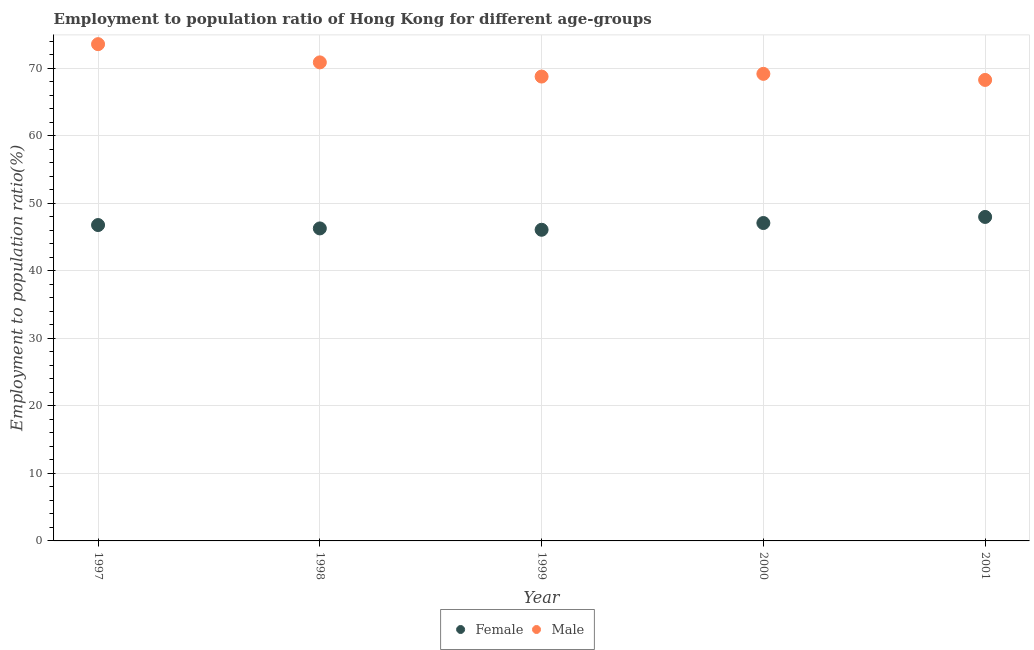Is the number of dotlines equal to the number of legend labels?
Offer a terse response. Yes. What is the employment to population ratio(male) in 1998?
Keep it short and to the point. 70.9. Across all years, what is the maximum employment to population ratio(female)?
Provide a succinct answer. 48. Across all years, what is the minimum employment to population ratio(female)?
Give a very brief answer. 46.1. In which year was the employment to population ratio(male) minimum?
Your answer should be very brief. 2001. What is the total employment to population ratio(male) in the graph?
Your answer should be very brief. 350.8. What is the difference between the employment to population ratio(female) in 1997 and that in 1998?
Give a very brief answer. 0.5. What is the difference between the employment to population ratio(female) in 1997 and the employment to population ratio(male) in 2001?
Offer a terse response. -21.5. What is the average employment to population ratio(female) per year?
Your response must be concise. 46.86. In the year 2000, what is the difference between the employment to population ratio(female) and employment to population ratio(male)?
Keep it short and to the point. -22.1. What is the ratio of the employment to population ratio(male) in 1999 to that in 2000?
Provide a succinct answer. 0.99. Is the employment to population ratio(male) in 1997 less than that in 2000?
Provide a short and direct response. No. What is the difference between the highest and the second highest employment to population ratio(female)?
Keep it short and to the point. 0.9. What is the difference between the highest and the lowest employment to population ratio(male)?
Your answer should be compact. 5.3. In how many years, is the employment to population ratio(female) greater than the average employment to population ratio(female) taken over all years?
Keep it short and to the point. 2. Is the sum of the employment to population ratio(male) in 2000 and 2001 greater than the maximum employment to population ratio(female) across all years?
Make the answer very short. Yes. Is the employment to population ratio(male) strictly greater than the employment to population ratio(female) over the years?
Offer a terse response. Yes. Is the employment to population ratio(male) strictly less than the employment to population ratio(female) over the years?
Your answer should be very brief. No. How many dotlines are there?
Keep it short and to the point. 2. How many years are there in the graph?
Make the answer very short. 5. What is the difference between two consecutive major ticks on the Y-axis?
Your response must be concise. 10. Does the graph contain any zero values?
Give a very brief answer. No. How many legend labels are there?
Your response must be concise. 2. What is the title of the graph?
Your answer should be very brief. Employment to population ratio of Hong Kong for different age-groups. Does "Domestic Liabilities" appear as one of the legend labels in the graph?
Provide a succinct answer. No. What is the label or title of the X-axis?
Give a very brief answer. Year. What is the label or title of the Y-axis?
Provide a succinct answer. Employment to population ratio(%). What is the Employment to population ratio(%) of Female in 1997?
Your answer should be very brief. 46.8. What is the Employment to population ratio(%) of Male in 1997?
Keep it short and to the point. 73.6. What is the Employment to population ratio(%) of Female in 1998?
Offer a very short reply. 46.3. What is the Employment to population ratio(%) in Male in 1998?
Keep it short and to the point. 70.9. What is the Employment to population ratio(%) of Female in 1999?
Your answer should be very brief. 46.1. What is the Employment to population ratio(%) of Male in 1999?
Keep it short and to the point. 68.8. What is the Employment to population ratio(%) of Female in 2000?
Your answer should be compact. 47.1. What is the Employment to population ratio(%) in Male in 2000?
Provide a succinct answer. 69.2. What is the Employment to population ratio(%) of Female in 2001?
Keep it short and to the point. 48. What is the Employment to population ratio(%) in Male in 2001?
Offer a terse response. 68.3. Across all years, what is the maximum Employment to population ratio(%) in Male?
Ensure brevity in your answer.  73.6. Across all years, what is the minimum Employment to population ratio(%) of Female?
Give a very brief answer. 46.1. Across all years, what is the minimum Employment to population ratio(%) in Male?
Your answer should be very brief. 68.3. What is the total Employment to population ratio(%) in Female in the graph?
Your response must be concise. 234.3. What is the total Employment to population ratio(%) in Male in the graph?
Make the answer very short. 350.8. What is the difference between the Employment to population ratio(%) of Female in 1997 and that in 1998?
Your answer should be compact. 0.5. What is the difference between the Employment to population ratio(%) of Female in 1997 and that in 2000?
Your response must be concise. -0.3. What is the difference between the Employment to population ratio(%) in Female in 1997 and that in 2001?
Your answer should be compact. -1.2. What is the difference between the Employment to population ratio(%) of Female in 1998 and that in 1999?
Your response must be concise. 0.2. What is the difference between the Employment to population ratio(%) in Male in 1998 and that in 1999?
Give a very brief answer. 2.1. What is the difference between the Employment to population ratio(%) in Female in 1998 and that in 2000?
Offer a very short reply. -0.8. What is the difference between the Employment to population ratio(%) in Male in 1998 and that in 2000?
Keep it short and to the point. 1.7. What is the difference between the Employment to population ratio(%) in Female in 1998 and that in 2001?
Your response must be concise. -1.7. What is the difference between the Employment to population ratio(%) of Male in 1998 and that in 2001?
Provide a short and direct response. 2.6. What is the difference between the Employment to population ratio(%) of Male in 1999 and that in 2000?
Your answer should be very brief. -0.4. What is the difference between the Employment to population ratio(%) of Male in 1999 and that in 2001?
Your answer should be very brief. 0.5. What is the difference between the Employment to population ratio(%) of Male in 2000 and that in 2001?
Provide a succinct answer. 0.9. What is the difference between the Employment to population ratio(%) of Female in 1997 and the Employment to population ratio(%) of Male in 1998?
Give a very brief answer. -24.1. What is the difference between the Employment to population ratio(%) in Female in 1997 and the Employment to population ratio(%) in Male in 2000?
Offer a very short reply. -22.4. What is the difference between the Employment to population ratio(%) of Female in 1997 and the Employment to population ratio(%) of Male in 2001?
Make the answer very short. -21.5. What is the difference between the Employment to population ratio(%) of Female in 1998 and the Employment to population ratio(%) of Male in 1999?
Provide a succinct answer. -22.5. What is the difference between the Employment to population ratio(%) of Female in 1998 and the Employment to population ratio(%) of Male in 2000?
Give a very brief answer. -22.9. What is the difference between the Employment to population ratio(%) in Female in 1998 and the Employment to population ratio(%) in Male in 2001?
Make the answer very short. -22. What is the difference between the Employment to population ratio(%) of Female in 1999 and the Employment to population ratio(%) of Male in 2000?
Ensure brevity in your answer.  -23.1. What is the difference between the Employment to population ratio(%) in Female in 1999 and the Employment to population ratio(%) in Male in 2001?
Offer a terse response. -22.2. What is the difference between the Employment to population ratio(%) of Female in 2000 and the Employment to population ratio(%) of Male in 2001?
Provide a succinct answer. -21.2. What is the average Employment to population ratio(%) of Female per year?
Your response must be concise. 46.86. What is the average Employment to population ratio(%) of Male per year?
Provide a short and direct response. 70.16. In the year 1997, what is the difference between the Employment to population ratio(%) in Female and Employment to population ratio(%) in Male?
Your response must be concise. -26.8. In the year 1998, what is the difference between the Employment to population ratio(%) in Female and Employment to population ratio(%) in Male?
Offer a terse response. -24.6. In the year 1999, what is the difference between the Employment to population ratio(%) in Female and Employment to population ratio(%) in Male?
Offer a very short reply. -22.7. In the year 2000, what is the difference between the Employment to population ratio(%) in Female and Employment to population ratio(%) in Male?
Make the answer very short. -22.1. In the year 2001, what is the difference between the Employment to population ratio(%) of Female and Employment to population ratio(%) of Male?
Offer a very short reply. -20.3. What is the ratio of the Employment to population ratio(%) of Female in 1997 to that in 1998?
Keep it short and to the point. 1.01. What is the ratio of the Employment to population ratio(%) in Male in 1997 to that in 1998?
Offer a very short reply. 1.04. What is the ratio of the Employment to population ratio(%) in Female in 1997 to that in 1999?
Give a very brief answer. 1.02. What is the ratio of the Employment to population ratio(%) in Male in 1997 to that in 1999?
Provide a short and direct response. 1.07. What is the ratio of the Employment to population ratio(%) of Male in 1997 to that in 2000?
Offer a very short reply. 1.06. What is the ratio of the Employment to population ratio(%) of Male in 1997 to that in 2001?
Provide a succinct answer. 1.08. What is the ratio of the Employment to population ratio(%) in Male in 1998 to that in 1999?
Your response must be concise. 1.03. What is the ratio of the Employment to population ratio(%) in Female in 1998 to that in 2000?
Your response must be concise. 0.98. What is the ratio of the Employment to population ratio(%) of Male in 1998 to that in 2000?
Your response must be concise. 1.02. What is the ratio of the Employment to population ratio(%) in Female in 1998 to that in 2001?
Your answer should be compact. 0.96. What is the ratio of the Employment to population ratio(%) in Male in 1998 to that in 2001?
Your answer should be very brief. 1.04. What is the ratio of the Employment to population ratio(%) of Female in 1999 to that in 2000?
Your answer should be compact. 0.98. What is the ratio of the Employment to population ratio(%) in Male in 1999 to that in 2000?
Ensure brevity in your answer.  0.99. What is the ratio of the Employment to population ratio(%) in Female in 1999 to that in 2001?
Give a very brief answer. 0.96. What is the ratio of the Employment to population ratio(%) in Male in 1999 to that in 2001?
Provide a short and direct response. 1.01. What is the ratio of the Employment to population ratio(%) in Female in 2000 to that in 2001?
Keep it short and to the point. 0.98. What is the ratio of the Employment to population ratio(%) in Male in 2000 to that in 2001?
Keep it short and to the point. 1.01. What is the difference between the highest and the second highest Employment to population ratio(%) in Female?
Provide a succinct answer. 0.9. What is the difference between the highest and the second highest Employment to population ratio(%) of Male?
Make the answer very short. 2.7. What is the difference between the highest and the lowest Employment to population ratio(%) in Female?
Provide a succinct answer. 1.9. 